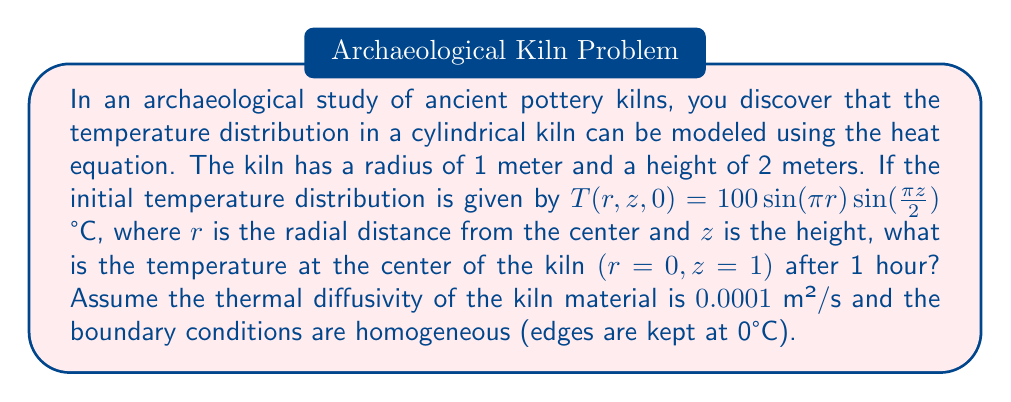Help me with this question. To solve this problem, we need to use the heat equation in cylindrical coordinates and apply separation of variables. Let's break it down step-by-step:

1) The heat equation in cylindrical coordinates with azimuthal symmetry is:

   $$\frac{\partial T}{\partial t} = \alpha \left(\frac{\partial^2 T}{\partial r^2} + \frac{1}{r}\frac{\partial T}{\partial r} + \frac{\partial^2 T}{\partial z^2}\right)$$

   where $\alpha$ is the thermal diffusivity.

2) The initial condition is $T(r,z,0) = 100\sin(\pi r)\sin(\frac{\pi z}{2})$ °C.

3) The boundary conditions are $T(1,z,t) = T(r,0,t) = T(r,2,t) = 0$.

4) We can separate the variables as $T(r,z,t) = R(r)Z(z)e^{-\lambda^2\alpha t}$.

5) Solving the radial equation, we get $R(r) = J_0(\beta r)$, where $J_0$ is the Bessel function of the first kind of order 0, and $\beta$ is chosen to satisfy the boundary condition at $r=1$. The first zero of $J_0$ is approximately 2.4048.

6) For the axial equation, we get $Z(z) = \sin(\frac{\pi z}{2})$.

7) Combining these, we have:

   $$T(r,z,t) = AJ_0(2.4048r)\sin(\frac{\pi z}{2})e^{-\lambda^2\alpha t}$$

   where $\lambda^2 = (2.4048)^2 + (\frac{\pi}{2})^2$.

8) Using the initial condition, we can determine $A = 100$.

9) Now, we can calculate the temperature at $(r=0, z=1)$ after 1 hour:

   $$T(0,1,3600) = 100J_0(0)\sin(\frac{\pi}{2})e^{-[(2.4048)^2 + (\frac{\pi}{2})^2] \cdot 0.0001 \cdot 3600}$$

10) Simplify:
    $J_0(0) = 1$, $\sin(\frac{\pi}{2}) = 1$
    
    $$T(0,1,3600) = 100 \cdot e^{-6.8365} \approx 0.1074 \text{ °C}$$
Answer: 0.1074 °C 